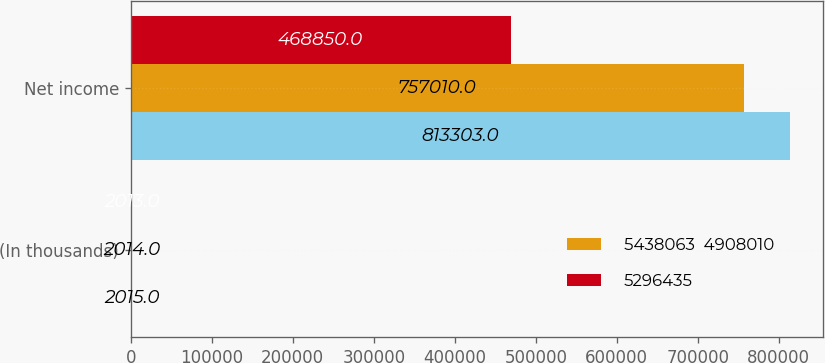Convert chart. <chart><loc_0><loc_0><loc_500><loc_500><stacked_bar_chart><ecel><fcel>(In thousands)<fcel>Net income<nl><fcel>nan<fcel>2015<fcel>813303<nl><fcel>5438063  4908010<fcel>2014<fcel>757010<nl><fcel>5296435<fcel>2013<fcel>468850<nl></chart> 